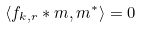<formula> <loc_0><loc_0><loc_500><loc_500>\langle f _ { k , r } \ast m , m ^ { * } \rangle = 0</formula> 